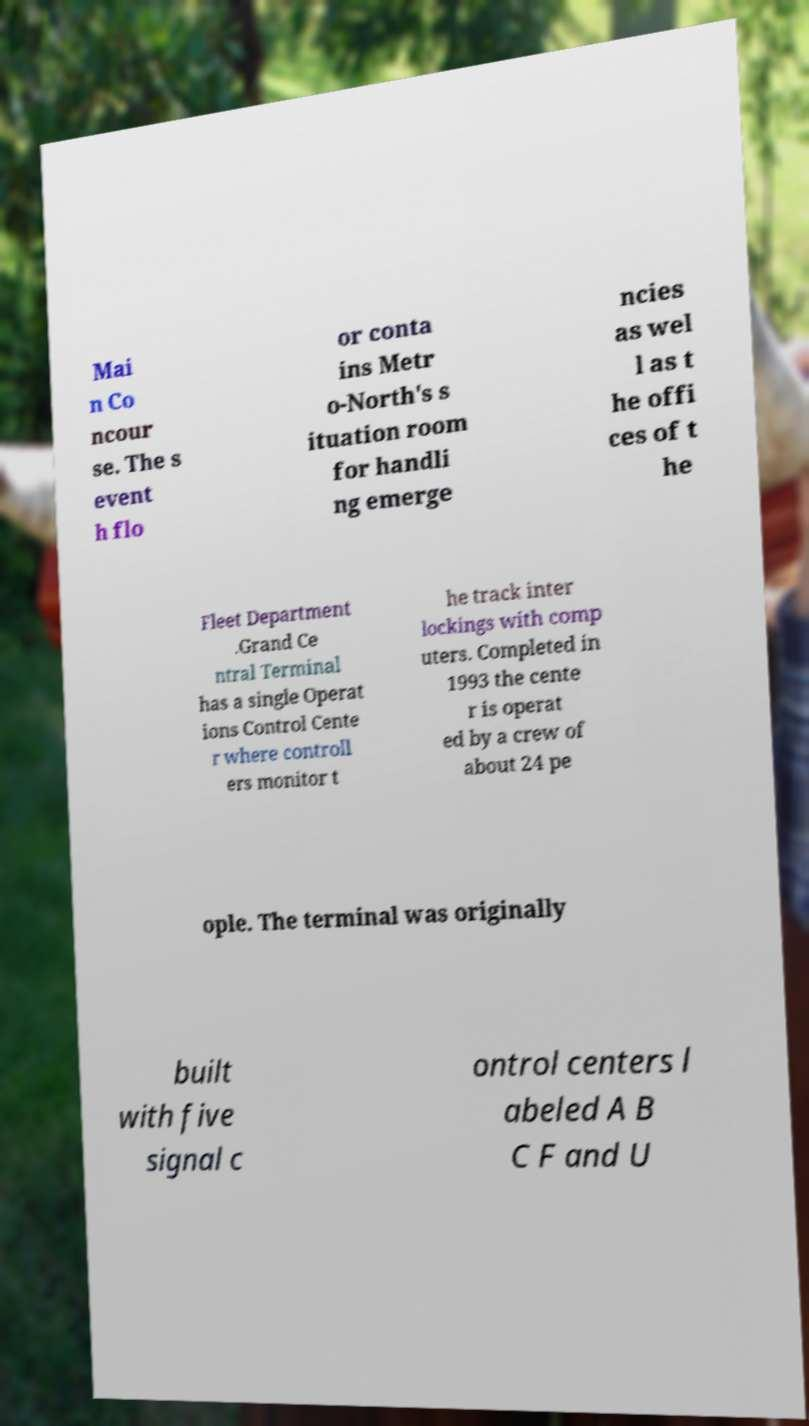Could you assist in decoding the text presented in this image and type it out clearly? Mai n Co ncour se. The s event h flo or conta ins Metr o-North's s ituation room for handli ng emerge ncies as wel l as t he offi ces of t he Fleet Department .Grand Ce ntral Terminal has a single Operat ions Control Cente r where controll ers monitor t he track inter lockings with comp uters. Completed in 1993 the cente r is operat ed by a crew of about 24 pe ople. The terminal was originally built with five signal c ontrol centers l abeled A B C F and U 